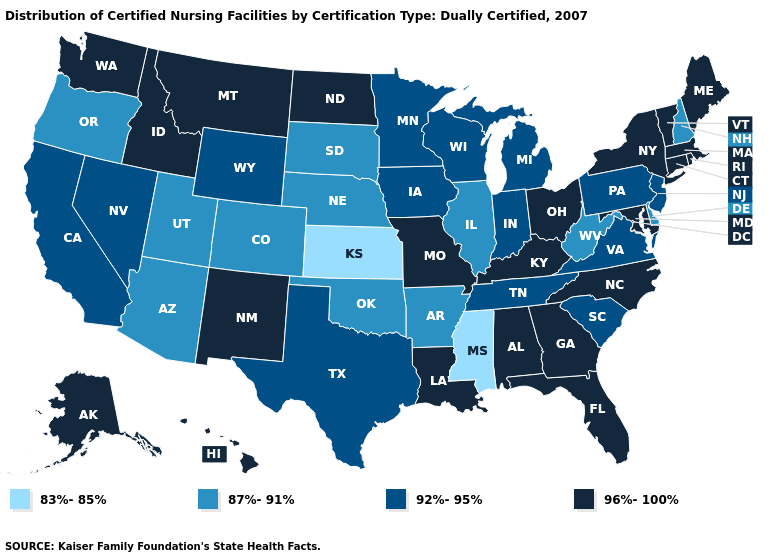Does California have a higher value than Colorado?
Write a very short answer. Yes. What is the value of Kansas?
Give a very brief answer. 83%-85%. Name the states that have a value in the range 96%-100%?
Answer briefly. Alabama, Alaska, Connecticut, Florida, Georgia, Hawaii, Idaho, Kentucky, Louisiana, Maine, Maryland, Massachusetts, Missouri, Montana, New Mexico, New York, North Carolina, North Dakota, Ohio, Rhode Island, Vermont, Washington. Name the states that have a value in the range 87%-91%?
Keep it brief. Arizona, Arkansas, Colorado, Delaware, Illinois, Nebraska, New Hampshire, Oklahoma, Oregon, South Dakota, Utah, West Virginia. Does Mississippi have the lowest value in the South?
Quick response, please. Yes. What is the value of North Carolina?
Be succinct. 96%-100%. What is the value of Georgia?
Concise answer only. 96%-100%. What is the value of North Carolina?
Give a very brief answer. 96%-100%. What is the value of North Dakota?
Be succinct. 96%-100%. Name the states that have a value in the range 96%-100%?
Be succinct. Alabama, Alaska, Connecticut, Florida, Georgia, Hawaii, Idaho, Kentucky, Louisiana, Maine, Maryland, Massachusetts, Missouri, Montana, New Mexico, New York, North Carolina, North Dakota, Ohio, Rhode Island, Vermont, Washington. Among the states that border Florida , which have the highest value?
Be succinct. Alabama, Georgia. Name the states that have a value in the range 83%-85%?
Keep it brief. Kansas, Mississippi. What is the highest value in states that border Mississippi?
Concise answer only. 96%-100%. Which states have the lowest value in the USA?
Keep it brief. Kansas, Mississippi. Does the map have missing data?
Write a very short answer. No. 